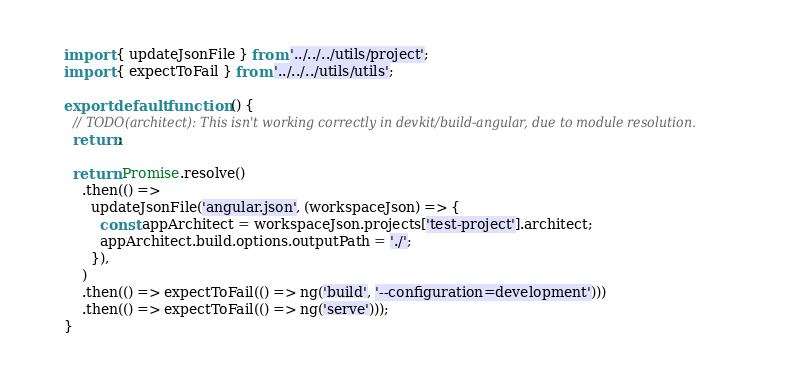<code> <loc_0><loc_0><loc_500><loc_500><_TypeScript_>import { updateJsonFile } from '../../../utils/project';
import { expectToFail } from '../../../utils/utils';

export default function () {
  // TODO(architect): This isn't working correctly in devkit/build-angular, due to module resolution.
  return;

  return Promise.resolve()
    .then(() =>
      updateJsonFile('angular.json', (workspaceJson) => {
        const appArchitect = workspaceJson.projects['test-project'].architect;
        appArchitect.build.options.outputPath = './';
      }),
    )
    .then(() => expectToFail(() => ng('build', '--configuration=development')))
    .then(() => expectToFail(() => ng('serve')));
}
</code> 